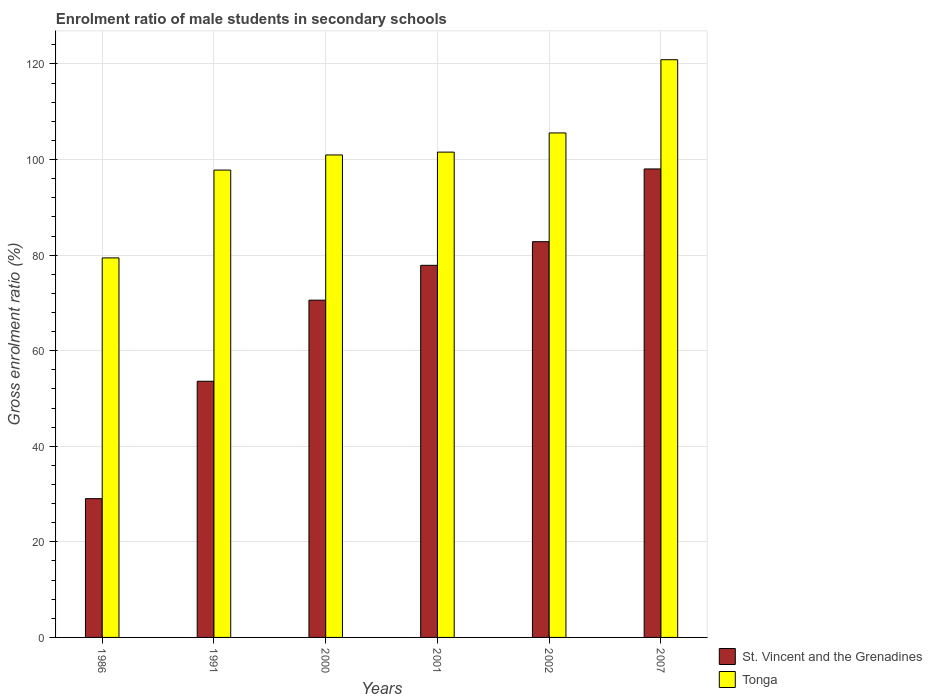How many groups of bars are there?
Your response must be concise. 6. Are the number of bars on each tick of the X-axis equal?
Give a very brief answer. Yes. In how many cases, is the number of bars for a given year not equal to the number of legend labels?
Your answer should be compact. 0. What is the enrolment ratio of male students in secondary schools in Tonga in 1986?
Give a very brief answer. 79.42. Across all years, what is the maximum enrolment ratio of male students in secondary schools in St. Vincent and the Grenadines?
Ensure brevity in your answer.  98.04. Across all years, what is the minimum enrolment ratio of male students in secondary schools in St. Vincent and the Grenadines?
Give a very brief answer. 29.04. In which year was the enrolment ratio of male students in secondary schools in Tonga minimum?
Keep it short and to the point. 1986. What is the total enrolment ratio of male students in secondary schools in St. Vincent and the Grenadines in the graph?
Your response must be concise. 411.95. What is the difference between the enrolment ratio of male students in secondary schools in St. Vincent and the Grenadines in 1991 and that in 2002?
Your response must be concise. -29.21. What is the difference between the enrolment ratio of male students in secondary schools in Tonga in 2000 and the enrolment ratio of male students in secondary schools in St. Vincent and the Grenadines in 1986?
Your answer should be very brief. 71.92. What is the average enrolment ratio of male students in secondary schools in Tonga per year?
Keep it short and to the point. 101.04. In the year 2000, what is the difference between the enrolment ratio of male students in secondary schools in St. Vincent and the Grenadines and enrolment ratio of male students in secondary schools in Tonga?
Keep it short and to the point. -30.38. In how many years, is the enrolment ratio of male students in secondary schools in Tonga greater than 48 %?
Make the answer very short. 6. What is the ratio of the enrolment ratio of male students in secondary schools in St. Vincent and the Grenadines in 1986 to that in 2007?
Provide a short and direct response. 0.3. Is the enrolment ratio of male students in secondary schools in Tonga in 2002 less than that in 2007?
Offer a very short reply. Yes. What is the difference between the highest and the second highest enrolment ratio of male students in secondary schools in St. Vincent and the Grenadines?
Your answer should be very brief. 15.22. What is the difference between the highest and the lowest enrolment ratio of male students in secondary schools in St. Vincent and the Grenadines?
Give a very brief answer. 69. Is the sum of the enrolment ratio of male students in secondary schools in St. Vincent and the Grenadines in 2002 and 2007 greater than the maximum enrolment ratio of male students in secondary schools in Tonga across all years?
Ensure brevity in your answer.  Yes. What does the 2nd bar from the left in 2007 represents?
Make the answer very short. Tonga. What does the 1st bar from the right in 2000 represents?
Provide a succinct answer. Tonga. How many bars are there?
Your answer should be very brief. 12. Are all the bars in the graph horizontal?
Your answer should be very brief. No. Are the values on the major ticks of Y-axis written in scientific E-notation?
Provide a succinct answer. No. Where does the legend appear in the graph?
Your answer should be very brief. Bottom right. How are the legend labels stacked?
Your answer should be very brief. Vertical. What is the title of the graph?
Your response must be concise. Enrolment ratio of male students in secondary schools. Does "Saudi Arabia" appear as one of the legend labels in the graph?
Your answer should be very brief. No. What is the label or title of the X-axis?
Ensure brevity in your answer.  Years. What is the Gross enrolment ratio (%) of St. Vincent and the Grenadines in 1986?
Offer a very short reply. 29.04. What is the Gross enrolment ratio (%) in Tonga in 1986?
Offer a very short reply. 79.42. What is the Gross enrolment ratio (%) of St. Vincent and the Grenadines in 1991?
Keep it short and to the point. 53.61. What is the Gross enrolment ratio (%) of Tonga in 1991?
Ensure brevity in your answer.  97.8. What is the Gross enrolment ratio (%) of St. Vincent and the Grenadines in 2000?
Make the answer very short. 70.58. What is the Gross enrolment ratio (%) in Tonga in 2000?
Offer a terse response. 100.96. What is the Gross enrolment ratio (%) in St. Vincent and the Grenadines in 2001?
Ensure brevity in your answer.  77.87. What is the Gross enrolment ratio (%) in Tonga in 2001?
Offer a terse response. 101.56. What is the Gross enrolment ratio (%) in St. Vincent and the Grenadines in 2002?
Your answer should be very brief. 82.82. What is the Gross enrolment ratio (%) in Tonga in 2002?
Your answer should be very brief. 105.57. What is the Gross enrolment ratio (%) in St. Vincent and the Grenadines in 2007?
Keep it short and to the point. 98.04. What is the Gross enrolment ratio (%) of Tonga in 2007?
Provide a short and direct response. 120.9. Across all years, what is the maximum Gross enrolment ratio (%) of St. Vincent and the Grenadines?
Give a very brief answer. 98.04. Across all years, what is the maximum Gross enrolment ratio (%) in Tonga?
Give a very brief answer. 120.9. Across all years, what is the minimum Gross enrolment ratio (%) of St. Vincent and the Grenadines?
Provide a short and direct response. 29.04. Across all years, what is the minimum Gross enrolment ratio (%) of Tonga?
Offer a very short reply. 79.42. What is the total Gross enrolment ratio (%) in St. Vincent and the Grenadines in the graph?
Your response must be concise. 411.95. What is the total Gross enrolment ratio (%) in Tonga in the graph?
Offer a terse response. 606.21. What is the difference between the Gross enrolment ratio (%) of St. Vincent and the Grenadines in 1986 and that in 1991?
Keep it short and to the point. -24.57. What is the difference between the Gross enrolment ratio (%) in Tonga in 1986 and that in 1991?
Offer a very short reply. -18.38. What is the difference between the Gross enrolment ratio (%) in St. Vincent and the Grenadines in 1986 and that in 2000?
Ensure brevity in your answer.  -41.54. What is the difference between the Gross enrolment ratio (%) of Tonga in 1986 and that in 2000?
Offer a very short reply. -21.54. What is the difference between the Gross enrolment ratio (%) of St. Vincent and the Grenadines in 1986 and that in 2001?
Your answer should be very brief. -48.83. What is the difference between the Gross enrolment ratio (%) in Tonga in 1986 and that in 2001?
Your answer should be compact. -22.13. What is the difference between the Gross enrolment ratio (%) in St. Vincent and the Grenadines in 1986 and that in 2002?
Ensure brevity in your answer.  -53.78. What is the difference between the Gross enrolment ratio (%) of Tonga in 1986 and that in 2002?
Provide a succinct answer. -26.15. What is the difference between the Gross enrolment ratio (%) in St. Vincent and the Grenadines in 1986 and that in 2007?
Make the answer very short. -69. What is the difference between the Gross enrolment ratio (%) in Tonga in 1986 and that in 2007?
Your response must be concise. -41.47. What is the difference between the Gross enrolment ratio (%) of St. Vincent and the Grenadines in 1991 and that in 2000?
Make the answer very short. -16.97. What is the difference between the Gross enrolment ratio (%) of Tonga in 1991 and that in 2000?
Offer a terse response. -3.16. What is the difference between the Gross enrolment ratio (%) of St. Vincent and the Grenadines in 1991 and that in 2001?
Offer a terse response. -24.26. What is the difference between the Gross enrolment ratio (%) in Tonga in 1991 and that in 2001?
Provide a short and direct response. -3.76. What is the difference between the Gross enrolment ratio (%) of St. Vincent and the Grenadines in 1991 and that in 2002?
Ensure brevity in your answer.  -29.21. What is the difference between the Gross enrolment ratio (%) in Tonga in 1991 and that in 2002?
Make the answer very short. -7.77. What is the difference between the Gross enrolment ratio (%) of St. Vincent and the Grenadines in 1991 and that in 2007?
Your response must be concise. -44.43. What is the difference between the Gross enrolment ratio (%) of Tonga in 1991 and that in 2007?
Your response must be concise. -23.09. What is the difference between the Gross enrolment ratio (%) of St. Vincent and the Grenadines in 2000 and that in 2001?
Your answer should be compact. -7.29. What is the difference between the Gross enrolment ratio (%) in Tonga in 2000 and that in 2001?
Provide a short and direct response. -0.6. What is the difference between the Gross enrolment ratio (%) in St. Vincent and the Grenadines in 2000 and that in 2002?
Your answer should be compact. -12.24. What is the difference between the Gross enrolment ratio (%) of Tonga in 2000 and that in 2002?
Your answer should be very brief. -4.61. What is the difference between the Gross enrolment ratio (%) in St. Vincent and the Grenadines in 2000 and that in 2007?
Your answer should be compact. -27.46. What is the difference between the Gross enrolment ratio (%) in Tonga in 2000 and that in 2007?
Keep it short and to the point. -19.93. What is the difference between the Gross enrolment ratio (%) in St. Vincent and the Grenadines in 2001 and that in 2002?
Offer a terse response. -4.95. What is the difference between the Gross enrolment ratio (%) of Tonga in 2001 and that in 2002?
Provide a succinct answer. -4.01. What is the difference between the Gross enrolment ratio (%) in St. Vincent and the Grenadines in 2001 and that in 2007?
Provide a short and direct response. -20.17. What is the difference between the Gross enrolment ratio (%) in Tonga in 2001 and that in 2007?
Ensure brevity in your answer.  -19.34. What is the difference between the Gross enrolment ratio (%) of St. Vincent and the Grenadines in 2002 and that in 2007?
Provide a short and direct response. -15.22. What is the difference between the Gross enrolment ratio (%) in Tonga in 2002 and that in 2007?
Ensure brevity in your answer.  -15.32. What is the difference between the Gross enrolment ratio (%) of St. Vincent and the Grenadines in 1986 and the Gross enrolment ratio (%) of Tonga in 1991?
Offer a terse response. -68.76. What is the difference between the Gross enrolment ratio (%) of St. Vincent and the Grenadines in 1986 and the Gross enrolment ratio (%) of Tonga in 2000?
Your answer should be compact. -71.92. What is the difference between the Gross enrolment ratio (%) of St. Vincent and the Grenadines in 1986 and the Gross enrolment ratio (%) of Tonga in 2001?
Provide a succinct answer. -72.52. What is the difference between the Gross enrolment ratio (%) in St. Vincent and the Grenadines in 1986 and the Gross enrolment ratio (%) in Tonga in 2002?
Offer a very short reply. -76.53. What is the difference between the Gross enrolment ratio (%) of St. Vincent and the Grenadines in 1986 and the Gross enrolment ratio (%) of Tonga in 2007?
Give a very brief answer. -91.86. What is the difference between the Gross enrolment ratio (%) of St. Vincent and the Grenadines in 1991 and the Gross enrolment ratio (%) of Tonga in 2000?
Your answer should be very brief. -47.35. What is the difference between the Gross enrolment ratio (%) of St. Vincent and the Grenadines in 1991 and the Gross enrolment ratio (%) of Tonga in 2001?
Keep it short and to the point. -47.95. What is the difference between the Gross enrolment ratio (%) of St. Vincent and the Grenadines in 1991 and the Gross enrolment ratio (%) of Tonga in 2002?
Keep it short and to the point. -51.96. What is the difference between the Gross enrolment ratio (%) in St. Vincent and the Grenadines in 1991 and the Gross enrolment ratio (%) in Tonga in 2007?
Offer a terse response. -67.29. What is the difference between the Gross enrolment ratio (%) of St. Vincent and the Grenadines in 2000 and the Gross enrolment ratio (%) of Tonga in 2001?
Provide a succinct answer. -30.98. What is the difference between the Gross enrolment ratio (%) of St. Vincent and the Grenadines in 2000 and the Gross enrolment ratio (%) of Tonga in 2002?
Your response must be concise. -34.99. What is the difference between the Gross enrolment ratio (%) of St. Vincent and the Grenadines in 2000 and the Gross enrolment ratio (%) of Tonga in 2007?
Provide a short and direct response. -50.32. What is the difference between the Gross enrolment ratio (%) of St. Vincent and the Grenadines in 2001 and the Gross enrolment ratio (%) of Tonga in 2002?
Make the answer very short. -27.7. What is the difference between the Gross enrolment ratio (%) in St. Vincent and the Grenadines in 2001 and the Gross enrolment ratio (%) in Tonga in 2007?
Give a very brief answer. -43.03. What is the difference between the Gross enrolment ratio (%) in St. Vincent and the Grenadines in 2002 and the Gross enrolment ratio (%) in Tonga in 2007?
Ensure brevity in your answer.  -38.08. What is the average Gross enrolment ratio (%) of St. Vincent and the Grenadines per year?
Provide a short and direct response. 68.66. What is the average Gross enrolment ratio (%) in Tonga per year?
Provide a short and direct response. 101.04. In the year 1986, what is the difference between the Gross enrolment ratio (%) of St. Vincent and the Grenadines and Gross enrolment ratio (%) of Tonga?
Your response must be concise. -50.38. In the year 1991, what is the difference between the Gross enrolment ratio (%) in St. Vincent and the Grenadines and Gross enrolment ratio (%) in Tonga?
Your answer should be compact. -44.2. In the year 2000, what is the difference between the Gross enrolment ratio (%) of St. Vincent and the Grenadines and Gross enrolment ratio (%) of Tonga?
Your response must be concise. -30.38. In the year 2001, what is the difference between the Gross enrolment ratio (%) in St. Vincent and the Grenadines and Gross enrolment ratio (%) in Tonga?
Ensure brevity in your answer.  -23.69. In the year 2002, what is the difference between the Gross enrolment ratio (%) in St. Vincent and the Grenadines and Gross enrolment ratio (%) in Tonga?
Provide a succinct answer. -22.76. In the year 2007, what is the difference between the Gross enrolment ratio (%) of St. Vincent and the Grenadines and Gross enrolment ratio (%) of Tonga?
Keep it short and to the point. -22.86. What is the ratio of the Gross enrolment ratio (%) in St. Vincent and the Grenadines in 1986 to that in 1991?
Provide a short and direct response. 0.54. What is the ratio of the Gross enrolment ratio (%) of Tonga in 1986 to that in 1991?
Offer a very short reply. 0.81. What is the ratio of the Gross enrolment ratio (%) of St. Vincent and the Grenadines in 1986 to that in 2000?
Provide a short and direct response. 0.41. What is the ratio of the Gross enrolment ratio (%) of Tonga in 1986 to that in 2000?
Keep it short and to the point. 0.79. What is the ratio of the Gross enrolment ratio (%) in St. Vincent and the Grenadines in 1986 to that in 2001?
Give a very brief answer. 0.37. What is the ratio of the Gross enrolment ratio (%) of Tonga in 1986 to that in 2001?
Your response must be concise. 0.78. What is the ratio of the Gross enrolment ratio (%) in St. Vincent and the Grenadines in 1986 to that in 2002?
Your answer should be very brief. 0.35. What is the ratio of the Gross enrolment ratio (%) of Tonga in 1986 to that in 2002?
Provide a short and direct response. 0.75. What is the ratio of the Gross enrolment ratio (%) in St. Vincent and the Grenadines in 1986 to that in 2007?
Your answer should be very brief. 0.3. What is the ratio of the Gross enrolment ratio (%) of Tonga in 1986 to that in 2007?
Provide a succinct answer. 0.66. What is the ratio of the Gross enrolment ratio (%) in St. Vincent and the Grenadines in 1991 to that in 2000?
Your response must be concise. 0.76. What is the ratio of the Gross enrolment ratio (%) of Tonga in 1991 to that in 2000?
Ensure brevity in your answer.  0.97. What is the ratio of the Gross enrolment ratio (%) in St. Vincent and the Grenadines in 1991 to that in 2001?
Keep it short and to the point. 0.69. What is the ratio of the Gross enrolment ratio (%) of St. Vincent and the Grenadines in 1991 to that in 2002?
Provide a short and direct response. 0.65. What is the ratio of the Gross enrolment ratio (%) of Tonga in 1991 to that in 2002?
Keep it short and to the point. 0.93. What is the ratio of the Gross enrolment ratio (%) in St. Vincent and the Grenadines in 1991 to that in 2007?
Provide a succinct answer. 0.55. What is the ratio of the Gross enrolment ratio (%) in Tonga in 1991 to that in 2007?
Keep it short and to the point. 0.81. What is the ratio of the Gross enrolment ratio (%) of St. Vincent and the Grenadines in 2000 to that in 2001?
Make the answer very short. 0.91. What is the ratio of the Gross enrolment ratio (%) in St. Vincent and the Grenadines in 2000 to that in 2002?
Your answer should be very brief. 0.85. What is the ratio of the Gross enrolment ratio (%) of Tonga in 2000 to that in 2002?
Give a very brief answer. 0.96. What is the ratio of the Gross enrolment ratio (%) in St. Vincent and the Grenadines in 2000 to that in 2007?
Provide a succinct answer. 0.72. What is the ratio of the Gross enrolment ratio (%) in Tonga in 2000 to that in 2007?
Your answer should be very brief. 0.84. What is the ratio of the Gross enrolment ratio (%) in St. Vincent and the Grenadines in 2001 to that in 2002?
Provide a succinct answer. 0.94. What is the ratio of the Gross enrolment ratio (%) of Tonga in 2001 to that in 2002?
Make the answer very short. 0.96. What is the ratio of the Gross enrolment ratio (%) of St. Vincent and the Grenadines in 2001 to that in 2007?
Your answer should be compact. 0.79. What is the ratio of the Gross enrolment ratio (%) of Tonga in 2001 to that in 2007?
Provide a short and direct response. 0.84. What is the ratio of the Gross enrolment ratio (%) in St. Vincent and the Grenadines in 2002 to that in 2007?
Your answer should be very brief. 0.84. What is the ratio of the Gross enrolment ratio (%) in Tonga in 2002 to that in 2007?
Offer a very short reply. 0.87. What is the difference between the highest and the second highest Gross enrolment ratio (%) of St. Vincent and the Grenadines?
Offer a very short reply. 15.22. What is the difference between the highest and the second highest Gross enrolment ratio (%) in Tonga?
Provide a short and direct response. 15.32. What is the difference between the highest and the lowest Gross enrolment ratio (%) of St. Vincent and the Grenadines?
Provide a succinct answer. 69. What is the difference between the highest and the lowest Gross enrolment ratio (%) of Tonga?
Offer a terse response. 41.47. 